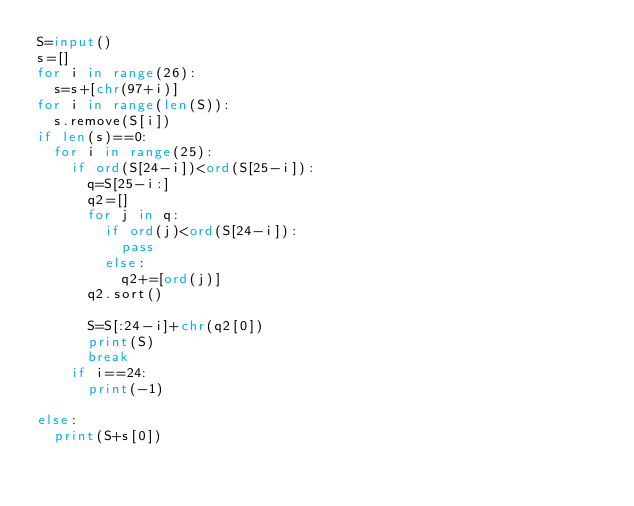Convert code to text. <code><loc_0><loc_0><loc_500><loc_500><_Python_>S=input()
s=[]
for i in range(26):
  s=s+[chr(97+i)]
for i in range(len(S)):
  s.remove(S[i])
if len(s)==0:
  for i in range(25):
    if ord(S[24-i])<ord(S[25-i]):
      q=S[25-i:]
      q2=[]
      for j in q:
        if ord(j)<ord(S[24-i]):
          pass
        else:
          q2+=[ord(j)]
      q2.sort()
      
      S=S[:24-i]+chr(q2[0])
      print(S)
      break
    if i==24:
      print(-1)
    
else:
  print(S+s[0])
</code> 